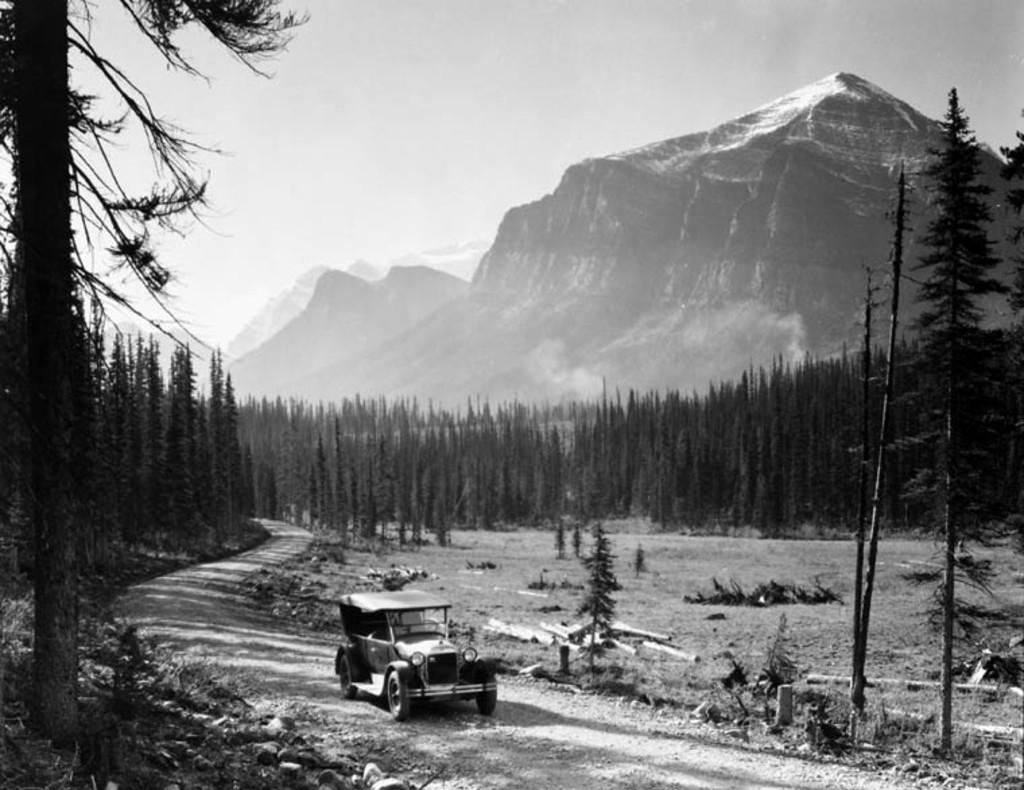What type of natural formation can be seen in the image? There are mountains in the image. What type of vegetation is present in the image? There are trees in the image. What can be used for walking or hiking in the image? There is a path in the image. What is visible in the sky in the image? The sky is visible in the image. What mode of transportation is present in the image? There is a vehicle in the image. Can you tell me how many people are crying at the desk in the image? There is no desk or people crying present in the image; it features mountains, trees, a path, the sky, and a vehicle. What type of experience can be gained from the mountains in the image? The image does not convey any specific experience related to the mountains; it simply shows their presence in the scene. 